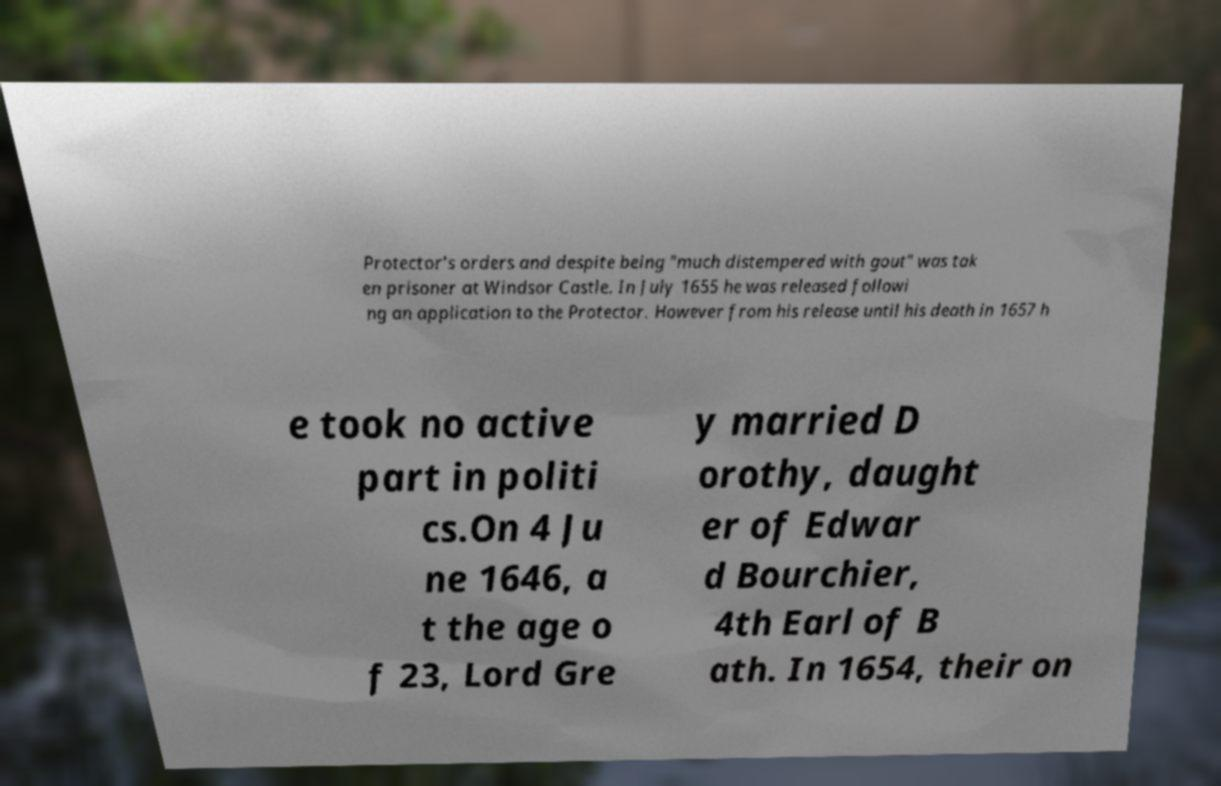Can you read and provide the text displayed in the image?This photo seems to have some interesting text. Can you extract and type it out for me? Protector's orders and despite being "much distempered with gout" was tak en prisoner at Windsor Castle. In July 1655 he was released followi ng an application to the Protector. However from his release until his death in 1657 h e took no active part in politi cs.On 4 Ju ne 1646, a t the age o f 23, Lord Gre y married D orothy, daught er of Edwar d Bourchier, 4th Earl of B ath. In 1654, their on 